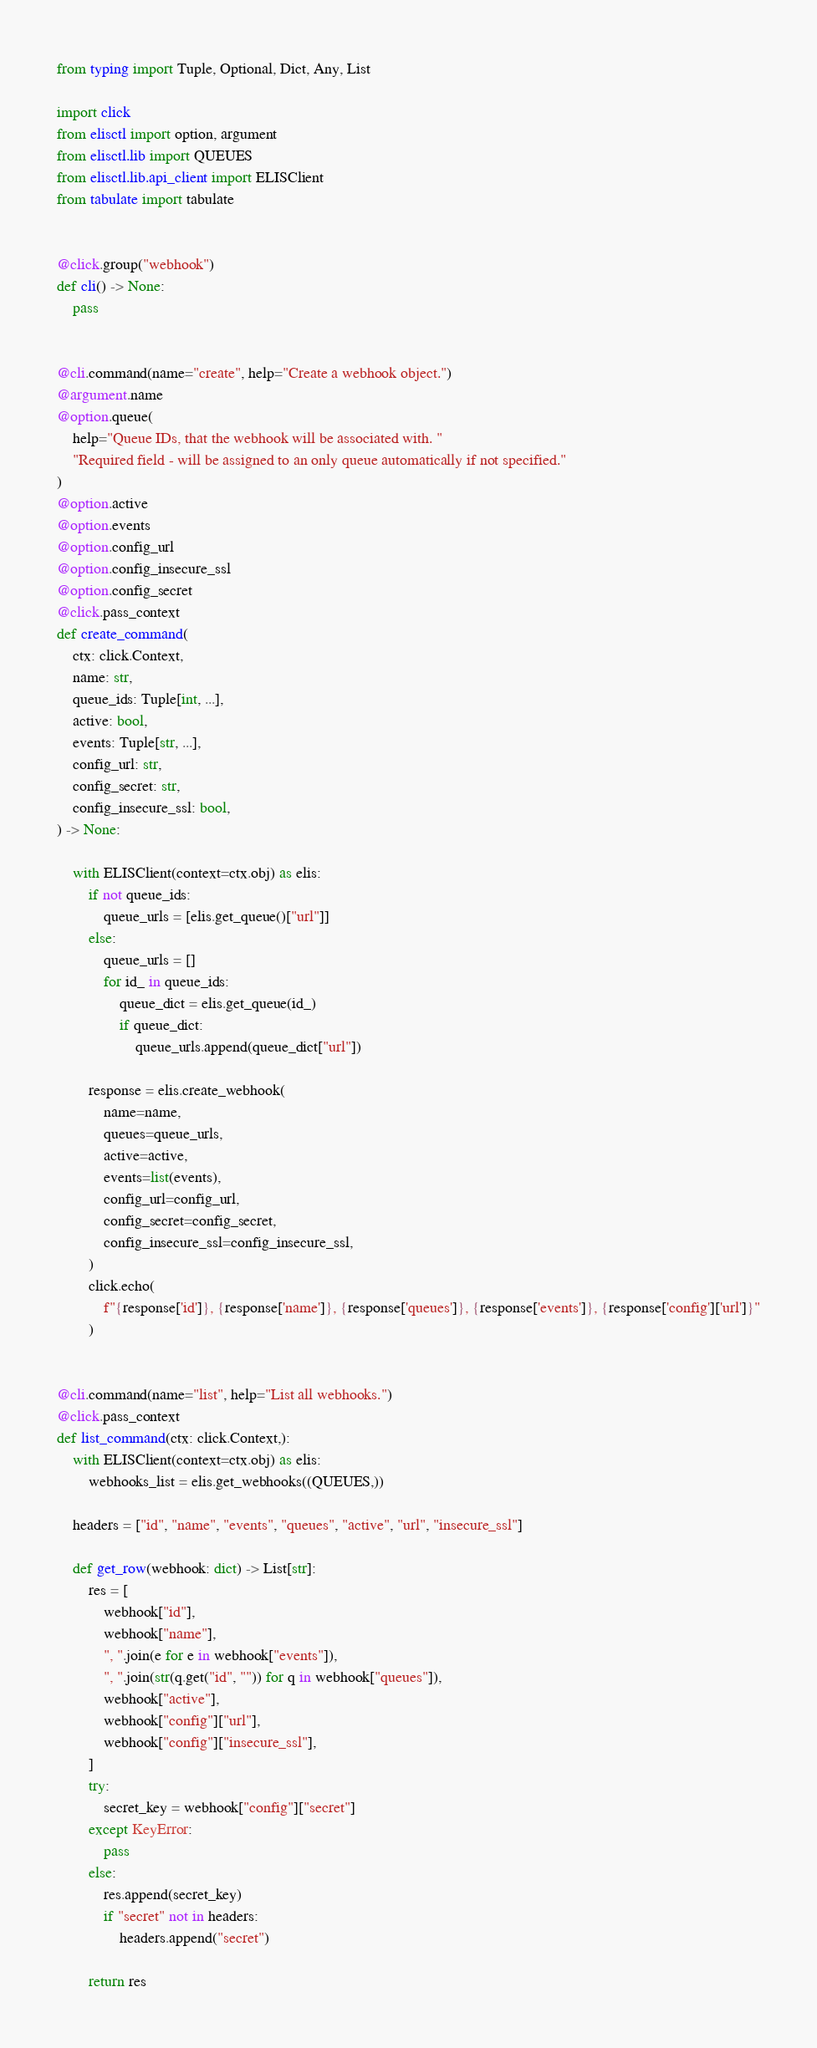<code> <loc_0><loc_0><loc_500><loc_500><_Python_>from typing import Tuple, Optional, Dict, Any, List

import click
from elisctl import option, argument
from elisctl.lib import QUEUES
from elisctl.lib.api_client import ELISClient
from tabulate import tabulate


@click.group("webhook")
def cli() -> None:
    pass


@cli.command(name="create", help="Create a webhook object.")
@argument.name
@option.queue(
    help="Queue IDs, that the webhook will be associated with. "
    "Required field - will be assigned to an only queue automatically if not specified."
)
@option.active
@option.events
@option.config_url
@option.config_insecure_ssl
@option.config_secret
@click.pass_context
def create_command(
    ctx: click.Context,
    name: str,
    queue_ids: Tuple[int, ...],
    active: bool,
    events: Tuple[str, ...],
    config_url: str,
    config_secret: str,
    config_insecure_ssl: bool,
) -> None:

    with ELISClient(context=ctx.obj) as elis:
        if not queue_ids:
            queue_urls = [elis.get_queue()["url"]]
        else:
            queue_urls = []
            for id_ in queue_ids:
                queue_dict = elis.get_queue(id_)
                if queue_dict:
                    queue_urls.append(queue_dict["url"])

        response = elis.create_webhook(
            name=name,
            queues=queue_urls,
            active=active,
            events=list(events),
            config_url=config_url,
            config_secret=config_secret,
            config_insecure_ssl=config_insecure_ssl,
        )
        click.echo(
            f"{response['id']}, {response['name']}, {response['queues']}, {response['events']}, {response['config']['url']}"
        )


@cli.command(name="list", help="List all webhooks.")
@click.pass_context
def list_command(ctx: click.Context,):
    with ELISClient(context=ctx.obj) as elis:
        webhooks_list = elis.get_webhooks((QUEUES,))

    headers = ["id", "name", "events", "queues", "active", "url", "insecure_ssl"]

    def get_row(webhook: dict) -> List[str]:
        res = [
            webhook["id"],
            webhook["name"],
            ", ".join(e for e in webhook["events"]),
            ", ".join(str(q.get("id", "")) for q in webhook["queues"]),
            webhook["active"],
            webhook["config"]["url"],
            webhook["config"]["insecure_ssl"],
        ]
        try:
            secret_key = webhook["config"]["secret"]
        except KeyError:
            pass
        else:
            res.append(secret_key)
            if "secret" not in headers:
                headers.append("secret")

        return res
</code> 